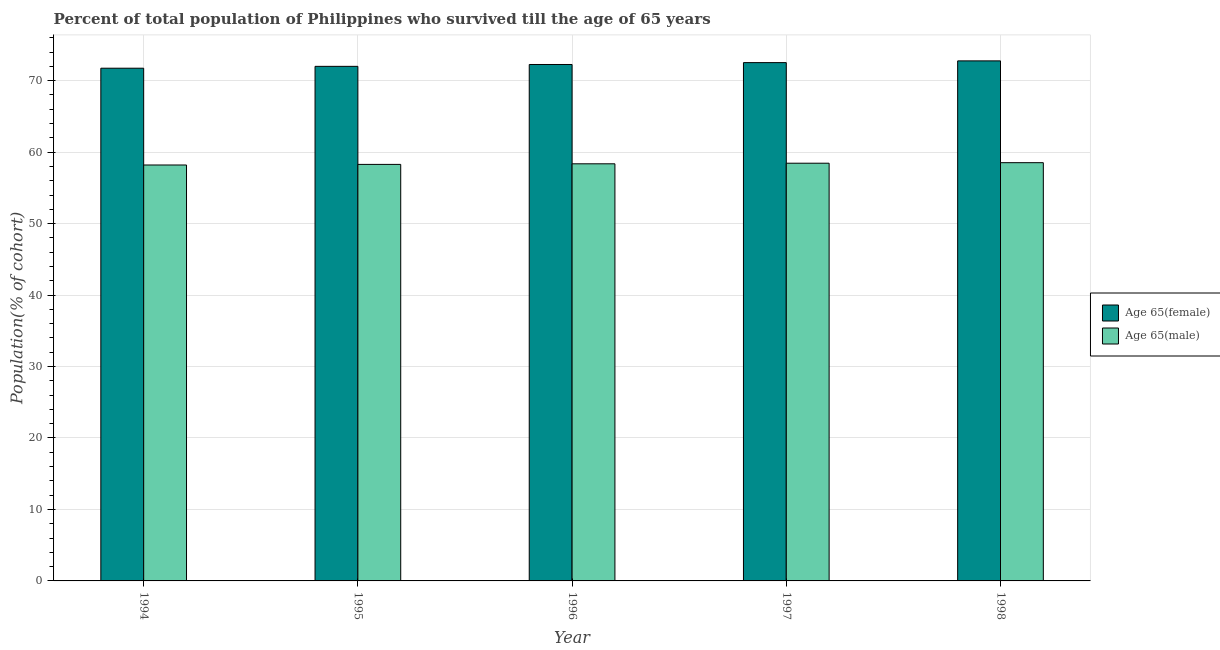How many different coloured bars are there?
Ensure brevity in your answer.  2. Are the number of bars per tick equal to the number of legend labels?
Your response must be concise. Yes. What is the percentage of female population who survived till age of 65 in 1997?
Offer a very short reply. 72.53. Across all years, what is the maximum percentage of male population who survived till age of 65?
Your response must be concise. 58.53. Across all years, what is the minimum percentage of female population who survived till age of 65?
Your answer should be very brief. 71.75. In which year was the percentage of female population who survived till age of 65 maximum?
Offer a very short reply. 1998. In which year was the percentage of male population who survived till age of 65 minimum?
Your answer should be very brief. 1994. What is the total percentage of male population who survived till age of 65 in the graph?
Your answer should be very brief. 291.83. What is the difference between the percentage of male population who survived till age of 65 in 1997 and that in 1998?
Provide a short and direct response. -0.07. What is the difference between the percentage of male population who survived till age of 65 in 1997 and the percentage of female population who survived till age of 65 in 1995?
Provide a short and direct response. 0.17. What is the average percentage of female population who survived till age of 65 per year?
Provide a short and direct response. 72.26. In how many years, is the percentage of female population who survived till age of 65 greater than 72 %?
Your answer should be very brief. 4. What is the ratio of the percentage of male population who survived till age of 65 in 1994 to that in 1995?
Make the answer very short. 1. Is the percentage of male population who survived till age of 65 in 1994 less than that in 1995?
Keep it short and to the point. Yes. Is the difference between the percentage of female population who survived till age of 65 in 1995 and 1996 greater than the difference between the percentage of male population who survived till age of 65 in 1995 and 1996?
Provide a succinct answer. No. What is the difference between the highest and the second highest percentage of male population who survived till age of 65?
Your response must be concise. 0.07. What is the difference between the highest and the lowest percentage of male population who survived till age of 65?
Ensure brevity in your answer.  0.32. In how many years, is the percentage of male population who survived till age of 65 greater than the average percentage of male population who survived till age of 65 taken over all years?
Provide a short and direct response. 3. What does the 1st bar from the left in 1997 represents?
Make the answer very short. Age 65(female). What does the 2nd bar from the right in 1996 represents?
Offer a very short reply. Age 65(female). Are all the bars in the graph horizontal?
Your answer should be very brief. No. Does the graph contain grids?
Offer a terse response. Yes. Where does the legend appear in the graph?
Provide a succinct answer. Center right. How many legend labels are there?
Your answer should be compact. 2. What is the title of the graph?
Give a very brief answer. Percent of total population of Philippines who survived till the age of 65 years. Does "Non-solid fuel" appear as one of the legend labels in the graph?
Make the answer very short. No. What is the label or title of the X-axis?
Offer a very short reply. Year. What is the label or title of the Y-axis?
Your answer should be compact. Population(% of cohort). What is the Population(% of cohort) in Age 65(female) in 1994?
Your response must be concise. 71.75. What is the Population(% of cohort) in Age 65(male) in 1994?
Offer a very short reply. 58.2. What is the Population(% of cohort) of Age 65(female) in 1995?
Provide a succinct answer. 72.01. What is the Population(% of cohort) of Age 65(male) in 1995?
Ensure brevity in your answer.  58.29. What is the Population(% of cohort) in Age 65(female) in 1996?
Provide a succinct answer. 72.27. What is the Population(% of cohort) in Age 65(male) in 1996?
Your answer should be very brief. 58.37. What is the Population(% of cohort) of Age 65(female) in 1997?
Your answer should be very brief. 72.53. What is the Population(% of cohort) of Age 65(male) in 1997?
Provide a succinct answer. 58.45. What is the Population(% of cohort) of Age 65(female) in 1998?
Offer a terse response. 72.77. What is the Population(% of cohort) of Age 65(male) in 1998?
Make the answer very short. 58.53. Across all years, what is the maximum Population(% of cohort) of Age 65(female)?
Give a very brief answer. 72.77. Across all years, what is the maximum Population(% of cohort) in Age 65(male)?
Offer a terse response. 58.53. Across all years, what is the minimum Population(% of cohort) in Age 65(female)?
Your answer should be very brief. 71.75. Across all years, what is the minimum Population(% of cohort) of Age 65(male)?
Provide a succinct answer. 58.2. What is the total Population(% of cohort) in Age 65(female) in the graph?
Make the answer very short. 361.32. What is the total Population(% of cohort) in Age 65(male) in the graph?
Give a very brief answer. 291.83. What is the difference between the Population(% of cohort) in Age 65(female) in 1994 and that in 1995?
Provide a short and direct response. -0.26. What is the difference between the Population(% of cohort) of Age 65(male) in 1994 and that in 1995?
Your response must be concise. -0.08. What is the difference between the Population(% of cohort) in Age 65(female) in 1994 and that in 1996?
Offer a very short reply. -0.52. What is the difference between the Population(% of cohort) in Age 65(male) in 1994 and that in 1996?
Your response must be concise. -0.17. What is the difference between the Population(% of cohort) of Age 65(female) in 1994 and that in 1997?
Keep it short and to the point. -0.78. What is the difference between the Population(% of cohort) of Age 65(male) in 1994 and that in 1997?
Provide a short and direct response. -0.25. What is the difference between the Population(% of cohort) of Age 65(female) in 1994 and that in 1998?
Your response must be concise. -1.03. What is the difference between the Population(% of cohort) in Age 65(male) in 1994 and that in 1998?
Make the answer very short. -0.32. What is the difference between the Population(% of cohort) of Age 65(female) in 1995 and that in 1996?
Keep it short and to the point. -0.26. What is the difference between the Population(% of cohort) in Age 65(male) in 1995 and that in 1996?
Your answer should be very brief. -0.08. What is the difference between the Population(% of cohort) in Age 65(female) in 1995 and that in 1997?
Make the answer very short. -0.52. What is the difference between the Population(% of cohort) of Age 65(male) in 1995 and that in 1997?
Provide a succinct answer. -0.17. What is the difference between the Population(% of cohort) of Age 65(female) in 1995 and that in 1998?
Ensure brevity in your answer.  -0.77. What is the difference between the Population(% of cohort) in Age 65(male) in 1995 and that in 1998?
Make the answer very short. -0.24. What is the difference between the Population(% of cohort) in Age 65(female) in 1996 and that in 1997?
Offer a terse response. -0.26. What is the difference between the Population(% of cohort) of Age 65(male) in 1996 and that in 1997?
Your response must be concise. -0.08. What is the difference between the Population(% of cohort) of Age 65(female) in 1996 and that in 1998?
Offer a terse response. -0.5. What is the difference between the Population(% of cohort) in Age 65(male) in 1996 and that in 1998?
Your answer should be compact. -0.16. What is the difference between the Population(% of cohort) in Age 65(female) in 1997 and that in 1998?
Your response must be concise. -0.24. What is the difference between the Population(% of cohort) in Age 65(male) in 1997 and that in 1998?
Make the answer very short. -0.07. What is the difference between the Population(% of cohort) in Age 65(female) in 1994 and the Population(% of cohort) in Age 65(male) in 1995?
Offer a terse response. 13.46. What is the difference between the Population(% of cohort) of Age 65(female) in 1994 and the Population(% of cohort) of Age 65(male) in 1996?
Offer a terse response. 13.38. What is the difference between the Population(% of cohort) in Age 65(female) in 1994 and the Population(% of cohort) in Age 65(male) in 1997?
Ensure brevity in your answer.  13.29. What is the difference between the Population(% of cohort) of Age 65(female) in 1994 and the Population(% of cohort) of Age 65(male) in 1998?
Make the answer very short. 13.22. What is the difference between the Population(% of cohort) in Age 65(female) in 1995 and the Population(% of cohort) in Age 65(male) in 1996?
Provide a short and direct response. 13.64. What is the difference between the Population(% of cohort) of Age 65(female) in 1995 and the Population(% of cohort) of Age 65(male) in 1997?
Make the answer very short. 13.55. What is the difference between the Population(% of cohort) of Age 65(female) in 1995 and the Population(% of cohort) of Age 65(male) in 1998?
Keep it short and to the point. 13.48. What is the difference between the Population(% of cohort) of Age 65(female) in 1996 and the Population(% of cohort) of Age 65(male) in 1997?
Ensure brevity in your answer.  13.81. What is the difference between the Population(% of cohort) of Age 65(female) in 1996 and the Population(% of cohort) of Age 65(male) in 1998?
Your answer should be very brief. 13.74. What is the difference between the Population(% of cohort) of Age 65(female) in 1997 and the Population(% of cohort) of Age 65(male) in 1998?
Offer a terse response. 14. What is the average Population(% of cohort) in Age 65(female) per year?
Provide a succinct answer. 72.26. What is the average Population(% of cohort) of Age 65(male) per year?
Provide a short and direct response. 58.37. In the year 1994, what is the difference between the Population(% of cohort) of Age 65(female) and Population(% of cohort) of Age 65(male)?
Provide a short and direct response. 13.54. In the year 1995, what is the difference between the Population(% of cohort) of Age 65(female) and Population(% of cohort) of Age 65(male)?
Offer a very short reply. 13.72. In the year 1996, what is the difference between the Population(% of cohort) of Age 65(female) and Population(% of cohort) of Age 65(male)?
Your response must be concise. 13.9. In the year 1997, what is the difference between the Population(% of cohort) in Age 65(female) and Population(% of cohort) in Age 65(male)?
Provide a short and direct response. 14.07. In the year 1998, what is the difference between the Population(% of cohort) of Age 65(female) and Population(% of cohort) of Age 65(male)?
Provide a succinct answer. 14.25. What is the ratio of the Population(% of cohort) of Age 65(female) in 1994 to that in 1996?
Provide a succinct answer. 0.99. What is the ratio of the Population(% of cohort) in Age 65(male) in 1994 to that in 1997?
Offer a terse response. 1. What is the ratio of the Population(% of cohort) in Age 65(female) in 1994 to that in 1998?
Make the answer very short. 0.99. What is the ratio of the Population(% of cohort) in Age 65(male) in 1994 to that in 1998?
Provide a short and direct response. 0.99. What is the ratio of the Population(% of cohort) in Age 65(male) in 1995 to that in 1996?
Offer a very short reply. 1. What is the ratio of the Population(% of cohort) of Age 65(female) in 1995 to that in 1997?
Offer a terse response. 0.99. What is the ratio of the Population(% of cohort) in Age 65(male) in 1995 to that in 1997?
Your answer should be compact. 1. What is the ratio of the Population(% of cohort) in Age 65(male) in 1996 to that in 1998?
Provide a succinct answer. 1. What is the ratio of the Population(% of cohort) of Age 65(female) in 1997 to that in 1998?
Provide a succinct answer. 1. What is the ratio of the Population(% of cohort) in Age 65(male) in 1997 to that in 1998?
Your answer should be very brief. 1. What is the difference between the highest and the second highest Population(% of cohort) of Age 65(female)?
Your answer should be very brief. 0.24. What is the difference between the highest and the second highest Population(% of cohort) of Age 65(male)?
Ensure brevity in your answer.  0.07. What is the difference between the highest and the lowest Population(% of cohort) of Age 65(female)?
Provide a short and direct response. 1.03. What is the difference between the highest and the lowest Population(% of cohort) of Age 65(male)?
Ensure brevity in your answer.  0.32. 